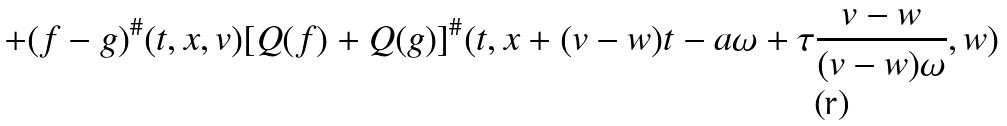Convert formula to latex. <formula><loc_0><loc_0><loc_500><loc_500>+ ( f - g ) ^ { \# } ( t , x , v ) [ Q ( f ) + Q ( g ) ] ^ { \# } ( t , x + ( v - w ) t - a \omega + \tau \frac { v - w } { ( v - w ) \omega } , w )</formula> 